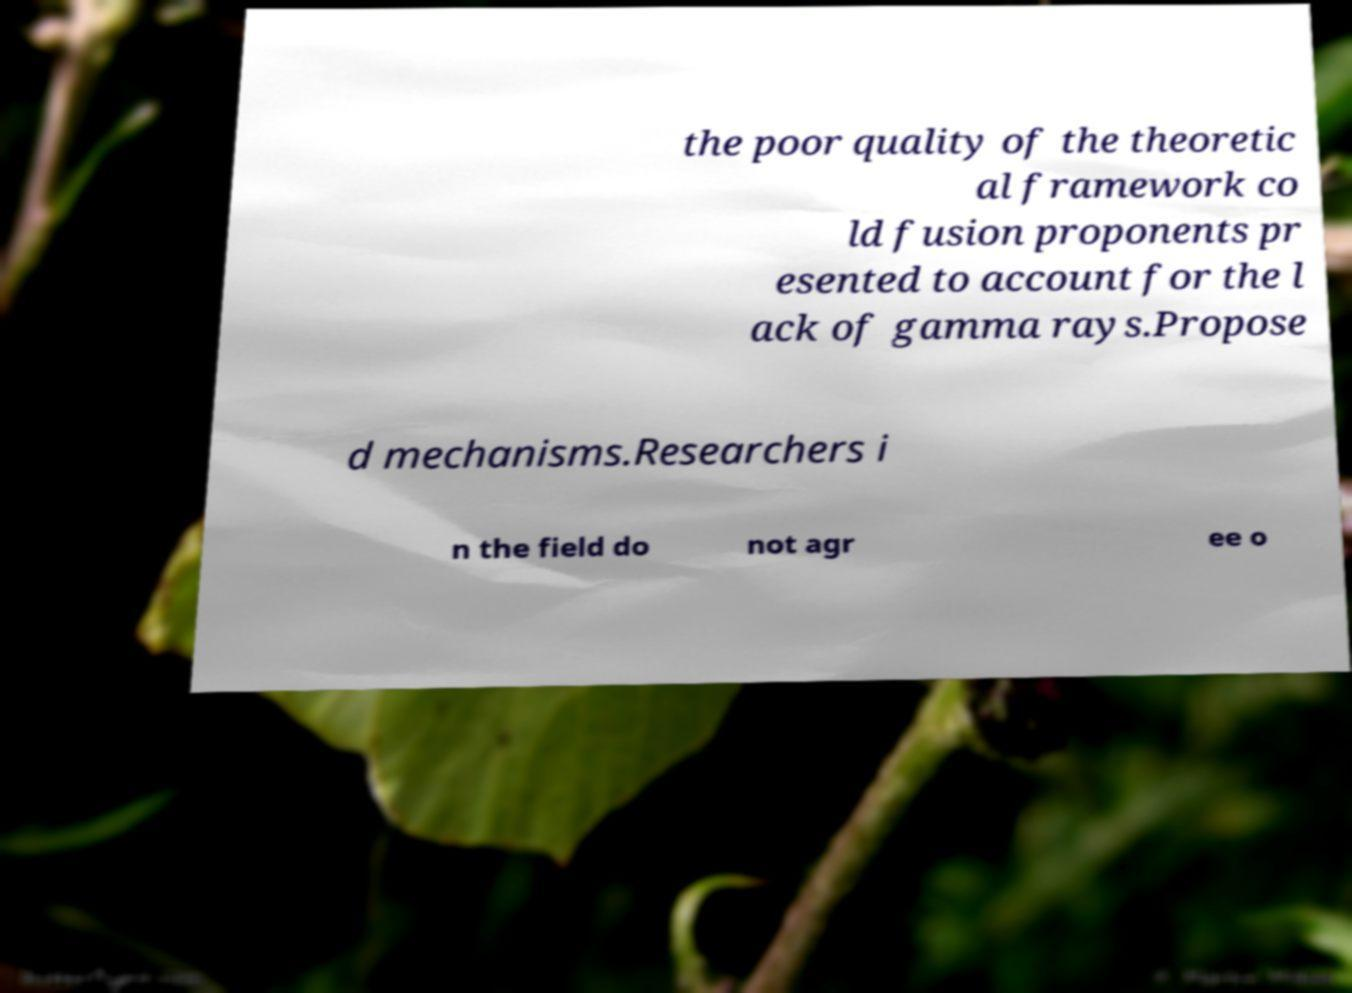For documentation purposes, I need the text within this image transcribed. Could you provide that? the poor quality of the theoretic al framework co ld fusion proponents pr esented to account for the l ack of gamma rays.Propose d mechanisms.Researchers i n the field do not agr ee o 